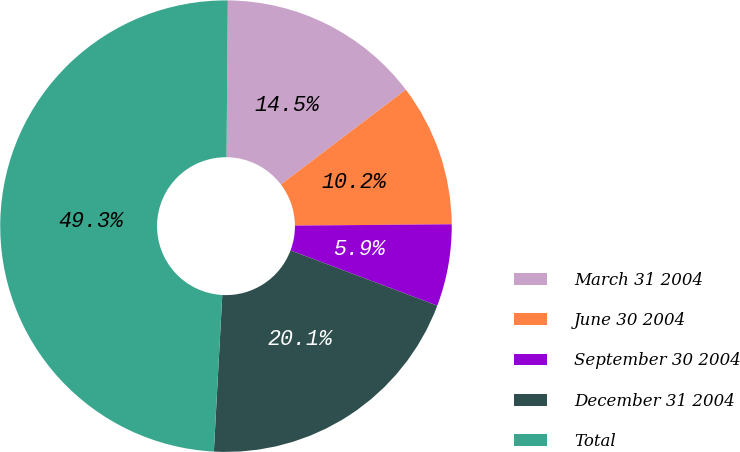Convert chart. <chart><loc_0><loc_0><loc_500><loc_500><pie_chart><fcel>March 31 2004<fcel>June 30 2004<fcel>September 30 2004<fcel>December 31 2004<fcel>Total<nl><fcel>14.54%<fcel>10.2%<fcel>5.86%<fcel>20.13%<fcel>49.28%<nl></chart> 